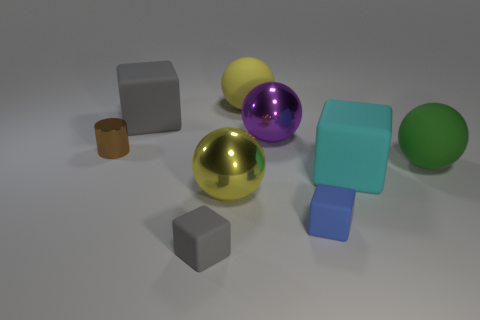Is the color of the large metallic thing that is in front of the large purple metal object the same as the rubber ball to the left of the small blue matte thing?
Make the answer very short. Yes. Is there a small blue cube made of the same material as the purple ball?
Provide a short and direct response. No. What number of objects are either balls on the right side of the big yellow rubber sphere or spheres in front of the large yellow matte sphere?
Ensure brevity in your answer.  3. How many other objects are there of the same color as the shiny cylinder?
Your answer should be very brief. 0. What material is the green sphere?
Your response must be concise. Rubber. There is a gray matte object in front of the brown cylinder; does it have the same size as the large cyan cube?
Your response must be concise. No. What is the size of the blue thing that is the same shape as the large cyan rubber thing?
Your answer should be very brief. Small. Are there an equal number of tiny shiny objects that are right of the big cyan matte object and yellow matte balls right of the purple sphere?
Ensure brevity in your answer.  Yes. How big is the gray thing in front of the large cyan object?
Provide a short and direct response. Small. Are there any other things that have the same shape as the yellow rubber object?
Offer a terse response. Yes. 